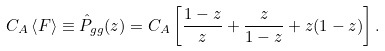<formula> <loc_0><loc_0><loc_500><loc_500>C _ { A } \left < F \right > \equiv \hat { P } _ { g g } ( z ) = C _ { A } \left [ \frac { 1 - z } { z } + \frac { z } { 1 - z } + z ( 1 - z ) \right ] .</formula> 